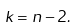Convert formula to latex. <formula><loc_0><loc_0><loc_500><loc_500>k = n - 2 .</formula> 